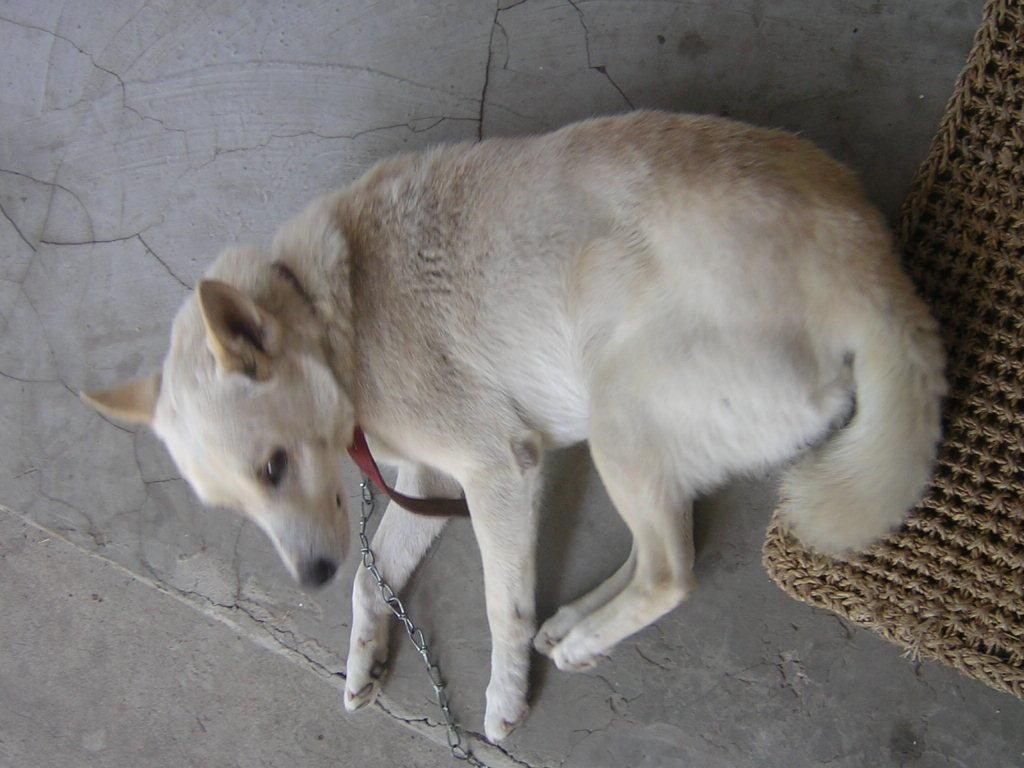What type of animal is in the image? There is a dog in the image. What color is the dog? The dog is light cream in color. What is on the floor in the image? There is a dog carpet on the floor in the image. What part of the dog's accessories can be seen in the image? There is a chain and a dog belt associated with the dog in the image. Can you hear the whistle in the image? There is no whistle present in the image, so it cannot be heard. 